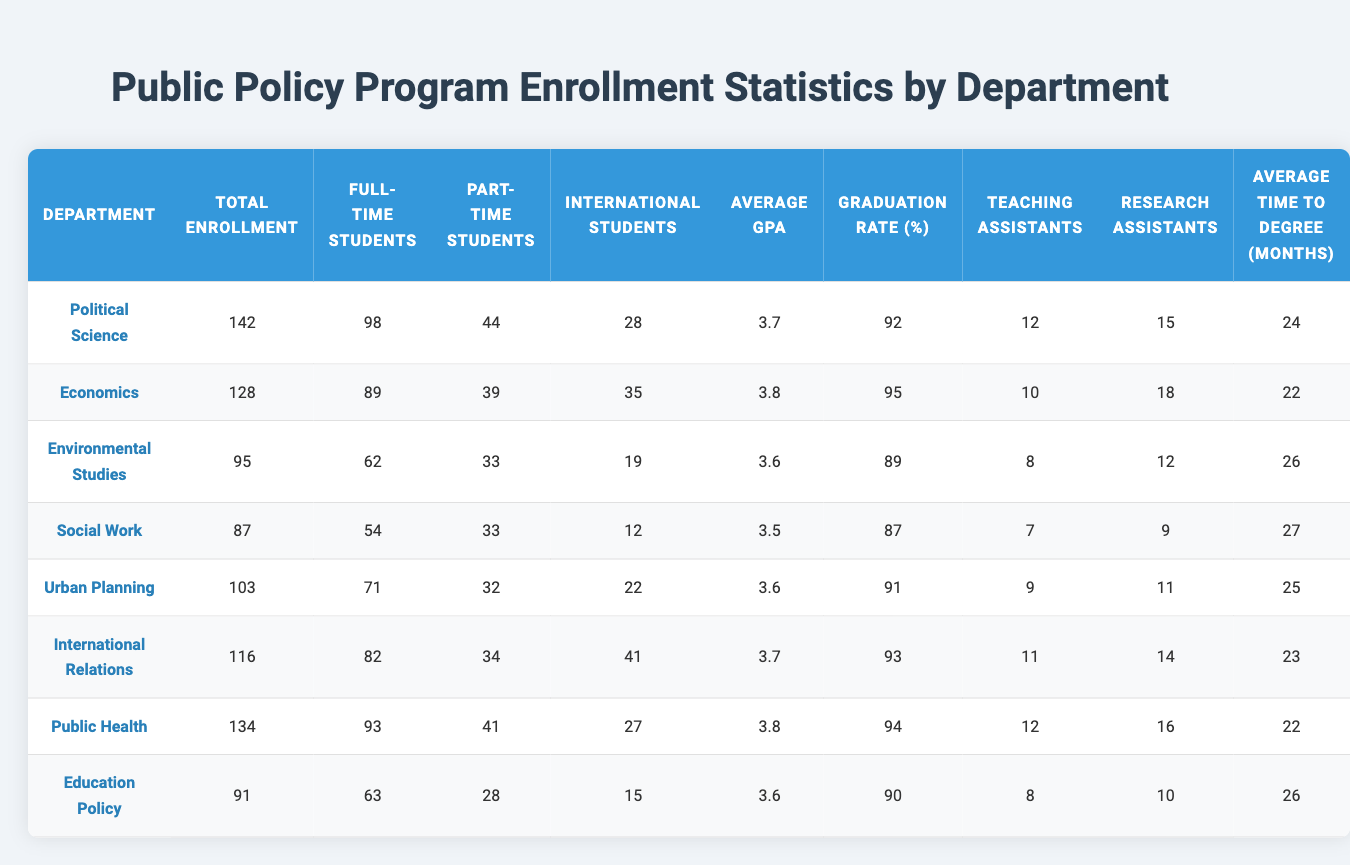What is the total enrollment for the Department of Environmental Studies? Looking at the table under the "Total Enrollment" column, the value for "Environmental Studies" is 95.
Answer: 95 Which department has the highest number of international students? By comparing the values in the "International Students" column, "International Relations" has the highest number with 41 students.
Answer: International Relations What is the average GPA for the Department of Public Health? The "Average GPA" for the "Public Health" department is listed as 3.8 in the table.
Answer: 3.8 How many full-time students are enrolled in the Urban Planning department? Referring to the "Full-Time Students" column, the Urban Planning department has 71 full-time students.
Answer: 71 What is the graduation rate for the Economics department? The graduation rate for the Economics department is found in the "Graduation Rate" column, which shows 95%.
Answer: 95% Is the average time to degree for the Social Work department longer than that for the Education Policy department? The "Average Time to Degree (Months)" for Social Work is 27 months, while for Education Policy it is 26 months. Since 27 is greater than 26, the answer is yes.
Answer: Yes What is the total number of part-time students across all departments? Summing up the "Part-Time Students" column: 44 + 39 + 33 + 33 + 32 + 34 + 41 + 28 = 314.
Answer: 314 Which department has the least number of teaching assistants? Comparing the "Teaching Assistants" column, "Social Work" has the least with 7 teaching assistants.
Answer: Social Work Calculate the average number of research assistants across all departments. Add the values from the "Research Assistants" column: (15 + 18 + 12 + 9 + 11 + 14 + 16 + 10) = 105, and then divide by 8 (the number of departments), resulting in an average of 13.125.
Answer: 13.125 Are there more full-time students than part-time students in the Department of Political Science? The "Full-Time Students" for Political Science is 98 and "Part-Time Students" is 44. Since 98 is greater than 44, the answer is yes.
Answer: Yes 